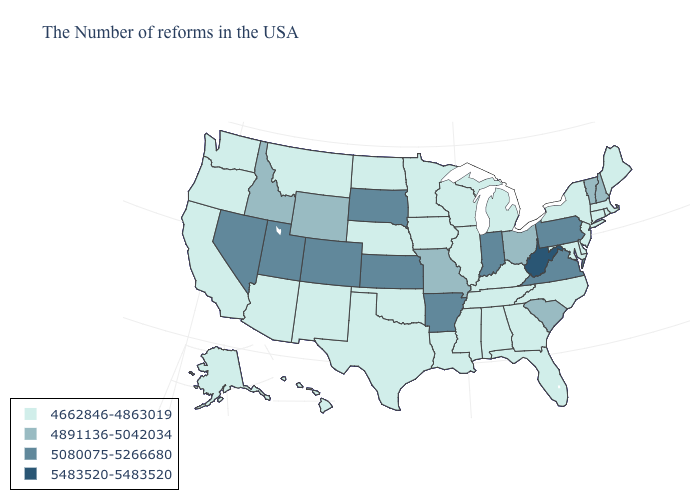Among the states that border Iowa , does Missouri have the lowest value?
Short answer required. No. What is the value of Alabama?
Short answer required. 4662846-4863019. Name the states that have a value in the range 4662846-4863019?
Be succinct. Maine, Massachusetts, Rhode Island, Connecticut, New York, New Jersey, Delaware, Maryland, North Carolina, Florida, Georgia, Michigan, Kentucky, Alabama, Tennessee, Wisconsin, Illinois, Mississippi, Louisiana, Minnesota, Iowa, Nebraska, Oklahoma, Texas, North Dakota, New Mexico, Montana, Arizona, California, Washington, Oregon, Alaska, Hawaii. Does Minnesota have the same value as Kansas?
Write a very short answer. No. Name the states that have a value in the range 4662846-4863019?
Give a very brief answer. Maine, Massachusetts, Rhode Island, Connecticut, New York, New Jersey, Delaware, Maryland, North Carolina, Florida, Georgia, Michigan, Kentucky, Alabama, Tennessee, Wisconsin, Illinois, Mississippi, Louisiana, Minnesota, Iowa, Nebraska, Oklahoma, Texas, North Dakota, New Mexico, Montana, Arizona, California, Washington, Oregon, Alaska, Hawaii. Name the states that have a value in the range 5483520-5483520?
Give a very brief answer. West Virginia. What is the highest value in states that border Wisconsin?
Give a very brief answer. 4662846-4863019. Is the legend a continuous bar?
Concise answer only. No. What is the lowest value in the Northeast?
Keep it brief. 4662846-4863019. What is the lowest value in states that border Maryland?
Quick response, please. 4662846-4863019. Does South Dakota have the lowest value in the USA?
Keep it brief. No. What is the value of West Virginia?
Keep it brief. 5483520-5483520. Name the states that have a value in the range 5080075-5266680?
Answer briefly. Pennsylvania, Virginia, Indiana, Arkansas, Kansas, South Dakota, Colorado, Utah, Nevada. What is the value of North Carolina?
Give a very brief answer. 4662846-4863019. 